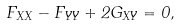Convert formula to latex. <formula><loc_0><loc_0><loc_500><loc_500>F _ { X X } - F _ { Y Y } + 2 G _ { X Y } = 0 ,</formula> 